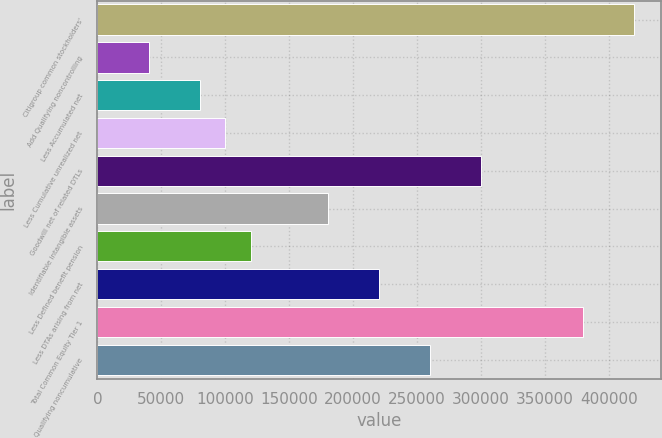<chart> <loc_0><loc_0><loc_500><loc_500><bar_chart><fcel>Citigroup common stockholders'<fcel>Add Qualifying noncontrolling<fcel>Less Accumulated net<fcel>Less Cumulative unrealized net<fcel>Goodwill net of related DTLs<fcel>Identifiable intangible assets<fcel>Less Defined benefit pension<fcel>Less DTAs arising from net<fcel>Total Common Equity Tier 1<fcel>Qualifying noncumulative<nl><fcel>419920<fcel>40039.4<fcel>80026.8<fcel>100020<fcel>299958<fcel>179995<fcel>120014<fcel>219983<fcel>379932<fcel>259970<nl></chart> 